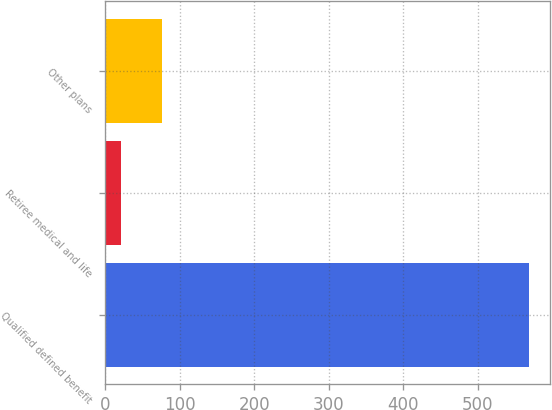Convert chart to OTSL. <chart><loc_0><loc_0><loc_500><loc_500><bar_chart><fcel>Qualified defined benefit<fcel>Retiree medical and life<fcel>Other plans<nl><fcel>568<fcel>22<fcel>76.6<nl></chart> 